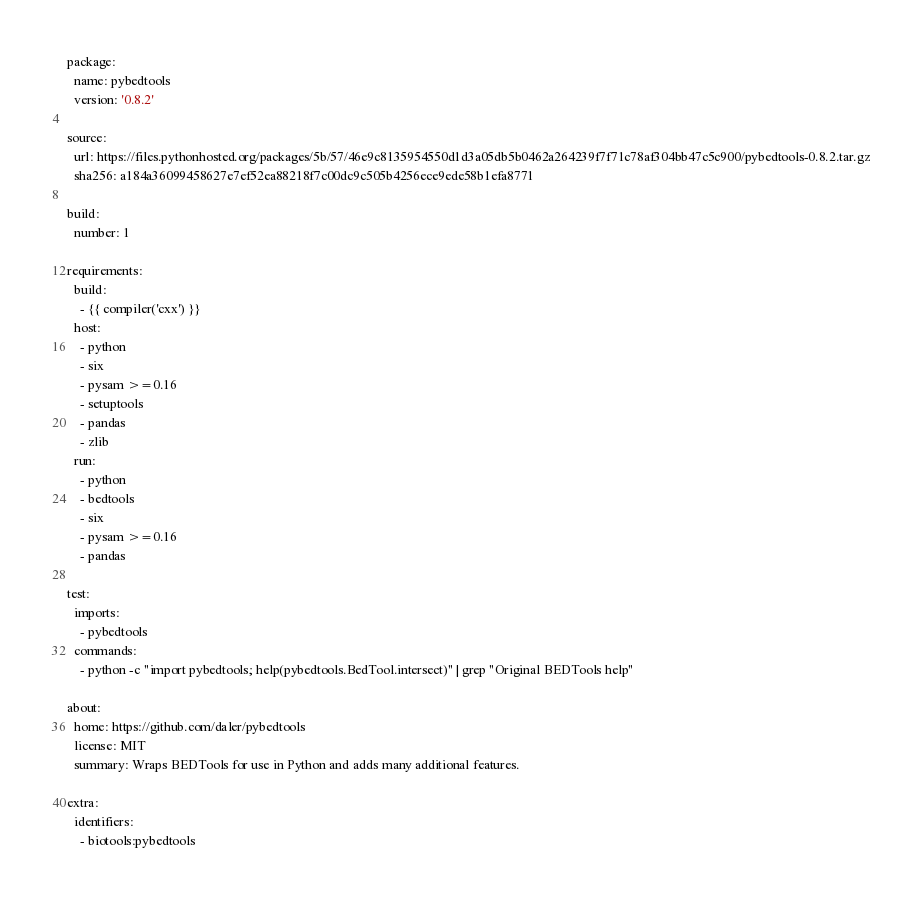Convert code to text. <code><loc_0><loc_0><loc_500><loc_500><_YAML_>package:
  name: pybedtools
  version: '0.8.2'

source:
  url: https://files.pythonhosted.org/packages/5b/57/46e9c8135954550d1d3a05db5b0462a264239f7f71c78af304bb47c5c900/pybedtools-0.8.2.tar.gz
  sha256: a184a36099458627e7ef52ea88218f7c00dc9c505b4256ece9ede58b1efa8771

build:
  number: 1

requirements:
  build:
    - {{ compiler('cxx') }}
  host:
    - python
    - six
    - pysam >=0.16
    - setuptools
    - pandas
    - zlib
  run:
    - python
    - bedtools
    - six
    - pysam >=0.16
    - pandas

test:
  imports:
    - pybedtools
  commands:
    - python -c "import pybedtools; help(pybedtools.BedTool.intersect)" | grep "Original BEDTools help"

about:
  home: https://github.com/daler/pybedtools
  license: MIT
  summary: Wraps BEDTools for use in Python and adds many additional features.

extra:
  identifiers:
    - biotools:pybedtools
</code> 